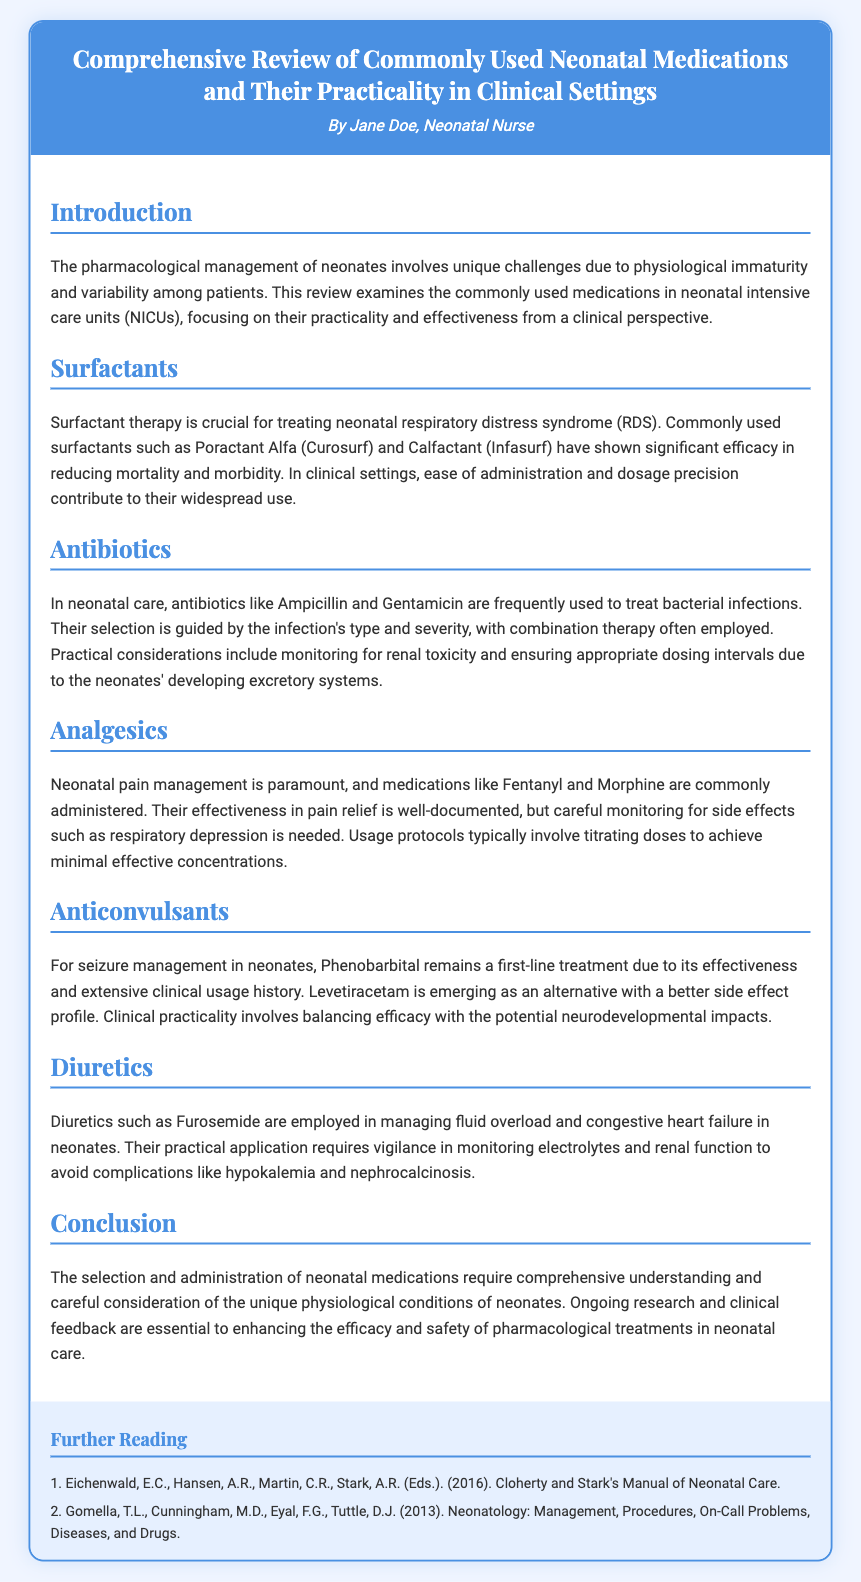What is the main topic of the Playbill? The main topic is about the review of neonatal medications and their practicality in clinical settings.
Answer: Comprehensive Review of Commonly Used Neonatal Medications and Their Practicality in Clinical Settings Who is the author of the Playbill? The author is identified at the top of the document.
Answer: Jane Doe What medication is crucial for treating neonatal respiratory distress syndrome? The document specifies a crucial therapy for neonatal respiratory distress syndrome.
Answer: Surfactant therapy Which antibiotics are frequently used in neonatal care? The review mentions specific antibiotics used in neonatal care.
Answer: Ampicillin and Gentamicin What is the first-line treatment for seizure management in neonates? The document states a primary medication used for seizures in neonates.
Answer: Phenobarbital What are the practical considerations when using diuretics in neonates? The document discusses necessary evaluations when administering certain medications.
Answer: Monitoring electrolytes and renal function Which drug has an emerging role with a better side effect profile for anticonvulsant treatment? The document mentions a newer alternative for anticonvulsants in the context of seizure management.
Answer: Levetiracetam What is emphasized as paramount in neonatal pain management? The text highlights a key aspect of managing pain in neonates.
Answer: Pain management What should be monitored with the use of antibiotics in neonates? The document points out an important side effect to observe when administering certain medications.
Answer: Renal toxicity 